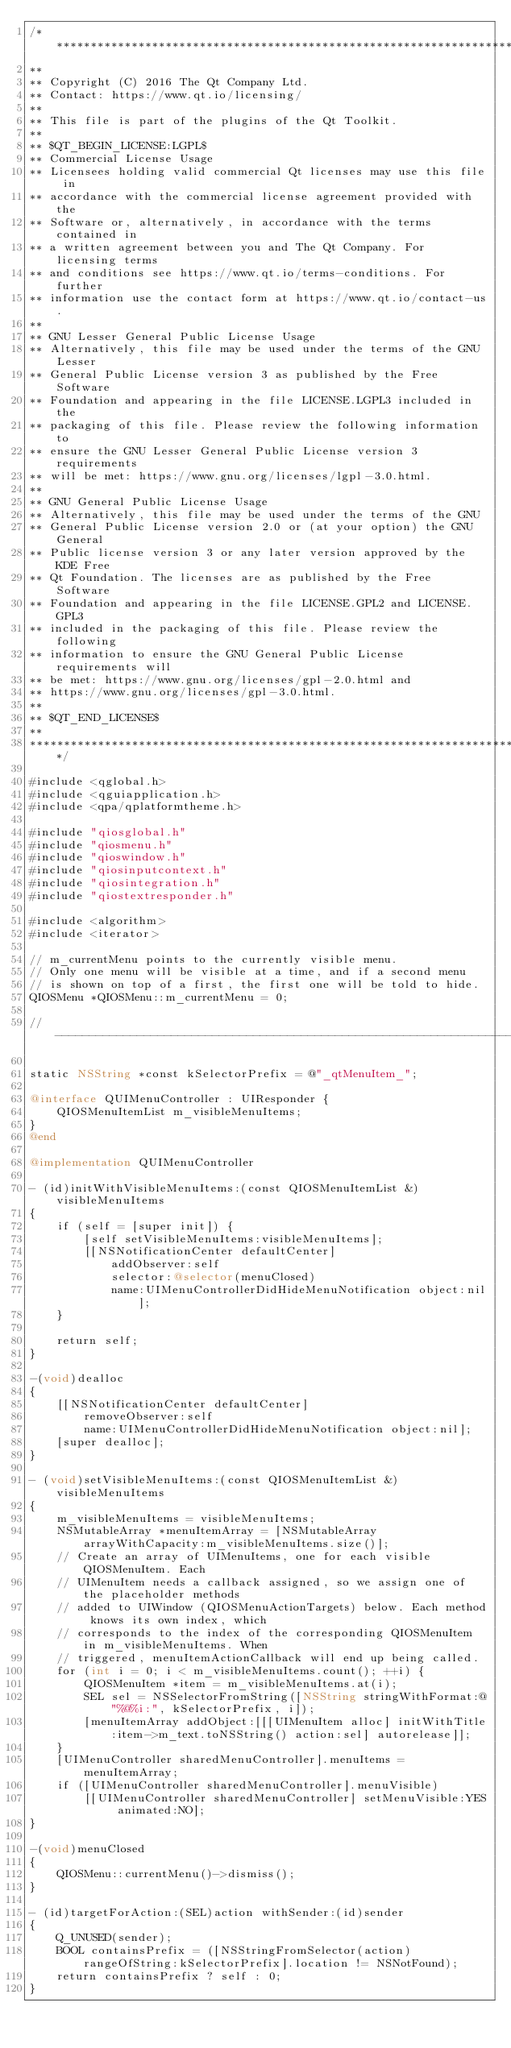Convert code to text. <code><loc_0><loc_0><loc_500><loc_500><_ObjectiveC_>/****************************************************************************
**
** Copyright (C) 2016 The Qt Company Ltd.
** Contact: https://www.qt.io/licensing/
**
** This file is part of the plugins of the Qt Toolkit.
**
** $QT_BEGIN_LICENSE:LGPL$
** Commercial License Usage
** Licensees holding valid commercial Qt licenses may use this file in
** accordance with the commercial license agreement provided with the
** Software or, alternatively, in accordance with the terms contained in
** a written agreement between you and The Qt Company. For licensing terms
** and conditions see https://www.qt.io/terms-conditions. For further
** information use the contact form at https://www.qt.io/contact-us.
**
** GNU Lesser General Public License Usage
** Alternatively, this file may be used under the terms of the GNU Lesser
** General Public License version 3 as published by the Free Software
** Foundation and appearing in the file LICENSE.LGPL3 included in the
** packaging of this file. Please review the following information to
** ensure the GNU Lesser General Public License version 3 requirements
** will be met: https://www.gnu.org/licenses/lgpl-3.0.html.
**
** GNU General Public License Usage
** Alternatively, this file may be used under the terms of the GNU
** General Public License version 2.0 or (at your option) the GNU General
** Public license version 3 or any later version approved by the KDE Free
** Qt Foundation. The licenses are as published by the Free Software
** Foundation and appearing in the file LICENSE.GPL2 and LICENSE.GPL3
** included in the packaging of this file. Please review the following
** information to ensure the GNU General Public License requirements will
** be met: https://www.gnu.org/licenses/gpl-2.0.html and
** https://www.gnu.org/licenses/gpl-3.0.html.
**
** $QT_END_LICENSE$
**
****************************************************************************/

#include <qglobal.h>
#include <qguiapplication.h>
#include <qpa/qplatformtheme.h>

#include "qiosglobal.h"
#include "qiosmenu.h"
#include "qioswindow.h"
#include "qiosinputcontext.h"
#include "qiosintegration.h"
#include "qiostextresponder.h"

#include <algorithm>
#include <iterator>

// m_currentMenu points to the currently visible menu.
// Only one menu will be visible at a time, and if a second menu
// is shown on top of a first, the first one will be told to hide.
QIOSMenu *QIOSMenu::m_currentMenu = 0;

// -------------------------------------------------------------------------

static NSString *const kSelectorPrefix = @"_qtMenuItem_";

@interface QUIMenuController : UIResponder {
    QIOSMenuItemList m_visibleMenuItems;
}
@end

@implementation QUIMenuController

- (id)initWithVisibleMenuItems:(const QIOSMenuItemList &)visibleMenuItems
{
    if (self = [super init]) {
        [self setVisibleMenuItems:visibleMenuItems];
        [[NSNotificationCenter defaultCenter]
            addObserver:self
            selector:@selector(menuClosed)
            name:UIMenuControllerDidHideMenuNotification object:nil];
    }

    return self;
}

-(void)dealloc
{
    [[NSNotificationCenter defaultCenter]
        removeObserver:self
        name:UIMenuControllerDidHideMenuNotification object:nil];
    [super dealloc];
}

- (void)setVisibleMenuItems:(const QIOSMenuItemList &)visibleMenuItems
{
    m_visibleMenuItems = visibleMenuItems;
    NSMutableArray *menuItemArray = [NSMutableArray arrayWithCapacity:m_visibleMenuItems.size()];
    // Create an array of UIMenuItems, one for each visible QIOSMenuItem. Each
    // UIMenuItem needs a callback assigned, so we assign one of the placeholder methods
    // added to UIWindow (QIOSMenuActionTargets) below. Each method knows its own index, which
    // corresponds to the index of the corresponding QIOSMenuItem in m_visibleMenuItems. When
    // triggered, menuItemActionCallback will end up being called.
    for (int i = 0; i < m_visibleMenuItems.count(); ++i) {
        QIOSMenuItem *item = m_visibleMenuItems.at(i);
        SEL sel = NSSelectorFromString([NSString stringWithFormat:@"%@%i:", kSelectorPrefix, i]);
        [menuItemArray addObject:[[[UIMenuItem alloc] initWithTitle:item->m_text.toNSString() action:sel] autorelease]];
    }
    [UIMenuController sharedMenuController].menuItems = menuItemArray;
    if ([UIMenuController sharedMenuController].menuVisible)
        [[UIMenuController sharedMenuController] setMenuVisible:YES animated:NO];
}

-(void)menuClosed
{
    QIOSMenu::currentMenu()->dismiss();
}

- (id)targetForAction:(SEL)action withSender:(id)sender
{
    Q_UNUSED(sender);
    BOOL containsPrefix = ([NSStringFromSelector(action) rangeOfString:kSelectorPrefix].location != NSNotFound);
    return containsPrefix ? self : 0;
}
</code> 